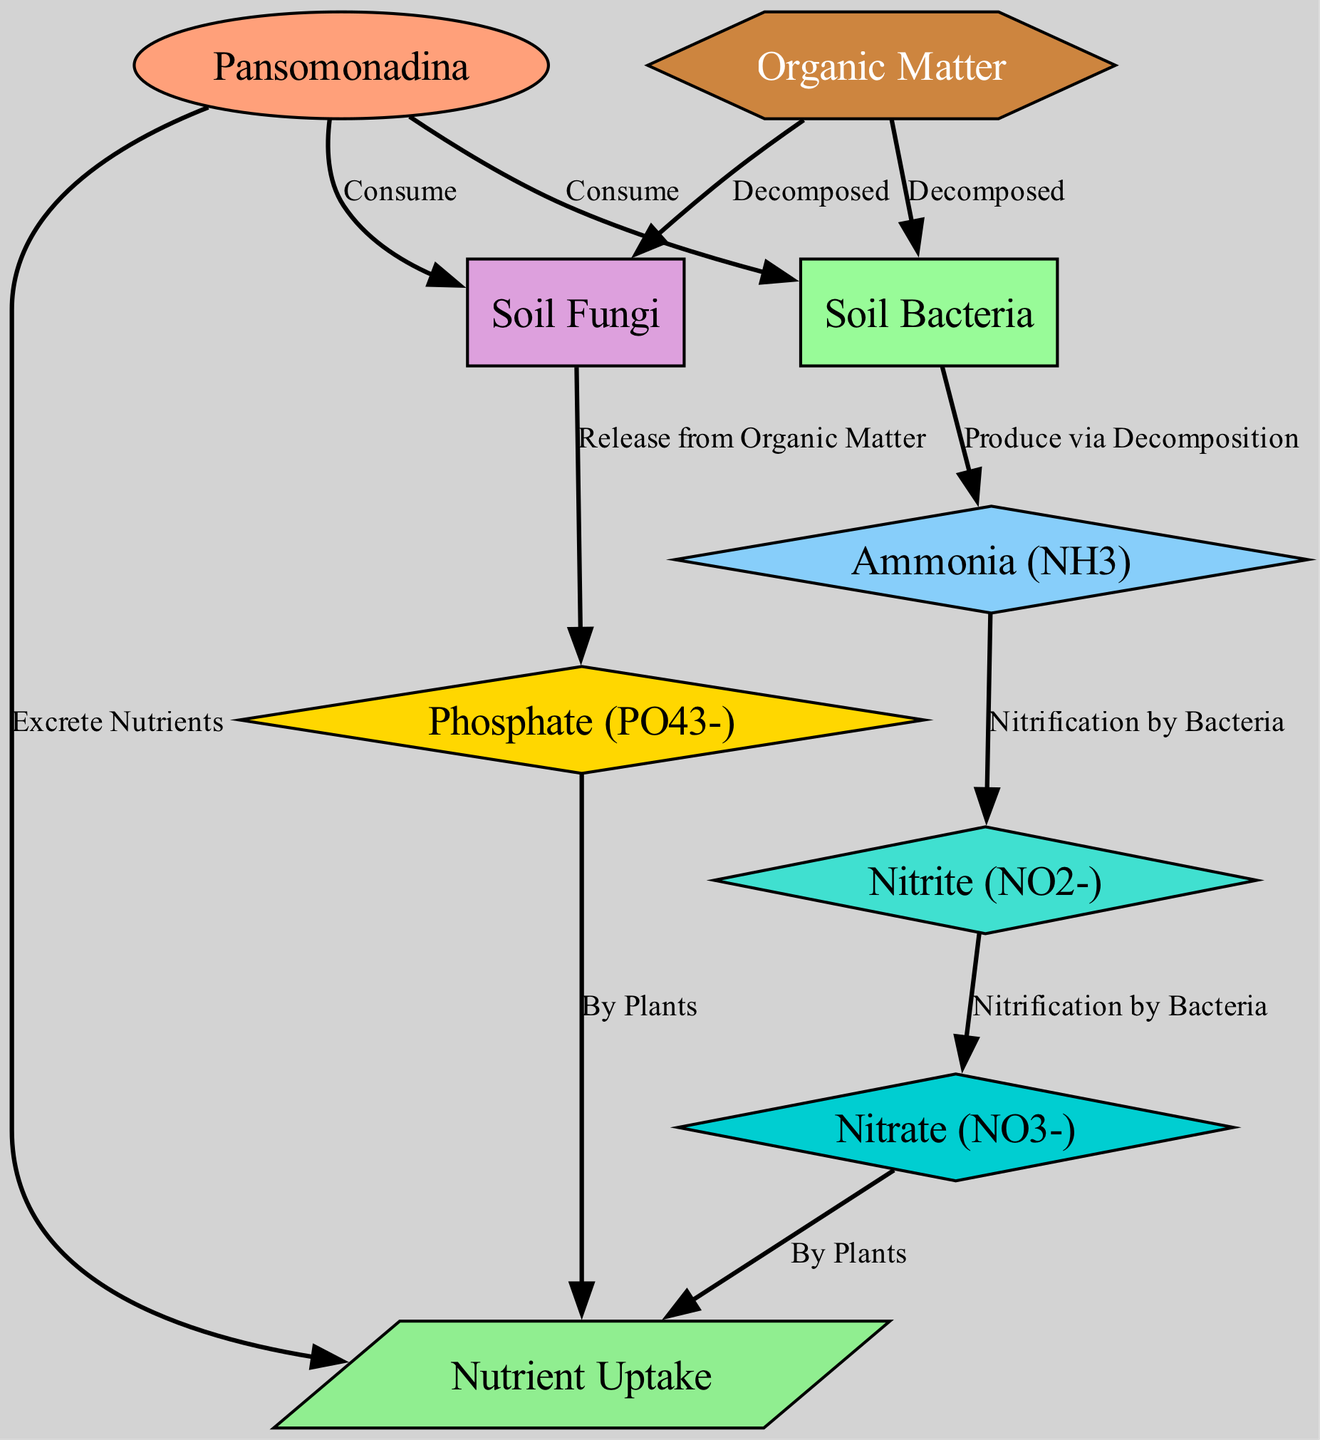What is the relationship between Pansomonadina and Soil Bacteria? The diagram shows that Pansomonadina consumes Soil Bacteria, indicating a direct interaction where Pansomonadina relies on Soil Bacteria for its nutrient cycle.
Answer: Consume How many nodes are in the diagram? By counting the unique entities listed in the nodes section of the diagram, there are a total of nine nodes representing different components in the nutrient cycling process.
Answer: 9 Which nutrient is produced by Soil Bacteria through decomposition? The diagram indicates that Soil Bacteria produce Ammonia via decomposition of Organic Matter, highlighting the role of Soil Bacteria in the nitrogen cycle.
Answer: Ammonia What nutrient do Soil Fungi release from Organic Matter? According to the diagram, Soil Fungi are shown to release Phosphate from Organic Matter which is essential for the nutrient cycle, particularly for the phosphorus cycle.
Answer: Phosphate What is the final nutrient uptake for plants according to the diagram? The diagram shows that both Nitrate and Phosphate are taken up by plants as part of the nutrient cycling process, highlighting the importance of these nutrients for plant growth.
Answer: Nitrate and Phosphate How many edges are connected to the Pansomonadina node? By examining the connections from the Pansomonadina node, we can see it has three directed edges leading to Soil Bacteria, Soil Fungi, and Nutrient Uptake, thus indicating its central role in the diagram.
Answer: 3 What process converts Ammonia to Nitrite? The diagram illustrates that Ammonia is converted into Nitrite through a process labeled as Nitrification by Bacteria, demonstrating the sequential transformations in the nitrogen cycle.
Answer: Nitrification by Bacteria What is the function of the Organic Matter node in the diagram? Organic Matter serves as a source of nutrients for Soil Bacteria and Soil Fungi, as depicted in the edges that show it being decomposed, thus playing an integral part in the nutrient cycling process.
Answer: Decomposed What color represents the Pansomonadina in the diagram? The visual representation shows Pansomonadina as having an oval shape filled with a light salmon color, specifically the hex code #FFA07A.
Answer: Light salmon 